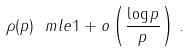<formula> <loc_0><loc_0><loc_500><loc_500>\rho ( p ) \ m l e 1 + o \left ( \frac { \log p } { p } \right ) \, .</formula> 